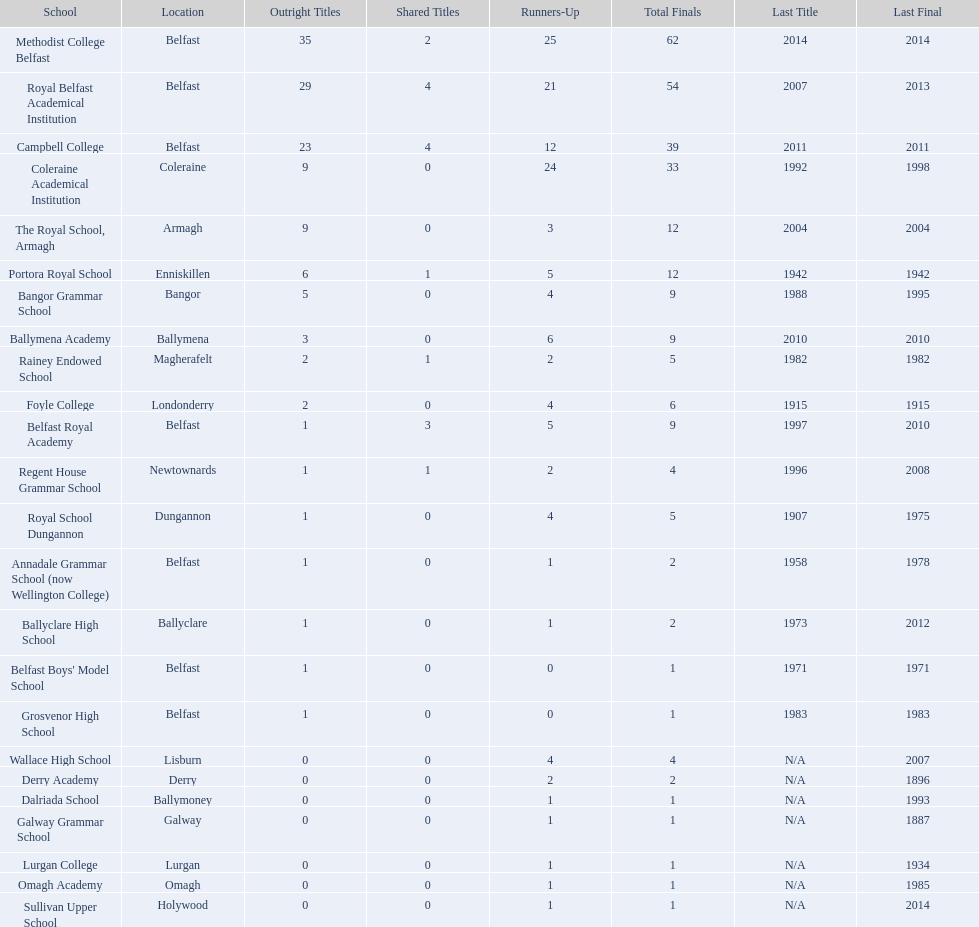How many educational institutions exist? Methodist College Belfast, Royal Belfast Academical Institution, Campbell College, Coleraine Academical Institution, The Royal School, Armagh, Portora Royal School, Bangor Grammar School, Ballymena Academy, Rainey Endowed School, Foyle College, Belfast Royal Academy, Regent House Grammar School, Royal School Dungannon, Annadale Grammar School (now Wellington College), Ballyclare High School, Belfast Boys' Model School, Grosvenor High School, Wallace High School, Derry Academy, Dalriada School, Galway Grammar School, Lurgan College, Omagh Academy, Sullivan Upper School. Can you give me this table as a dict? {'header': ['School', 'Location', 'Outright Titles', 'Shared Titles', 'Runners-Up', 'Total Finals', 'Last Title', 'Last Final'], 'rows': [['Methodist College Belfast', 'Belfast', '35', '2', '25', '62', '2014', '2014'], ['Royal Belfast Academical Institution', 'Belfast', '29', '4', '21', '54', '2007', '2013'], ['Campbell College', 'Belfast', '23', '4', '12', '39', '2011', '2011'], ['Coleraine Academical Institution', 'Coleraine', '9', '0', '24', '33', '1992', '1998'], ['The Royal School, Armagh', 'Armagh', '9', '0', '3', '12', '2004', '2004'], ['Portora Royal School', 'Enniskillen', '6', '1', '5', '12', '1942', '1942'], ['Bangor Grammar School', 'Bangor', '5', '0', '4', '9', '1988', '1995'], ['Ballymena Academy', 'Ballymena', '3', '0', '6', '9', '2010', '2010'], ['Rainey Endowed School', 'Magherafelt', '2', '1', '2', '5', '1982', '1982'], ['Foyle College', 'Londonderry', '2', '0', '4', '6', '1915', '1915'], ['Belfast Royal Academy', 'Belfast', '1', '3', '5', '9', '1997', '2010'], ['Regent House Grammar School', 'Newtownards', '1', '1', '2', '4', '1996', '2008'], ['Royal School Dungannon', 'Dungannon', '1', '0', '4', '5', '1907', '1975'], ['Annadale Grammar School (now Wellington College)', 'Belfast', '1', '0', '1', '2', '1958', '1978'], ['Ballyclare High School', 'Ballyclare', '1', '0', '1', '2', '1973', '2012'], ["Belfast Boys' Model School", 'Belfast', '1', '0', '0', '1', '1971', '1971'], ['Grosvenor High School', 'Belfast', '1', '0', '0', '1', '1983', '1983'], ['Wallace High School', 'Lisburn', '0', '0', '4', '4', 'N/A', '2007'], ['Derry Academy', 'Derry', '0', '0', '2', '2', 'N/A', '1896'], ['Dalriada School', 'Ballymoney', '0', '0', '1', '1', 'N/A', '1993'], ['Galway Grammar School', 'Galway', '0', '0', '1', '1', 'N/A', '1887'], ['Lurgan College', 'Lurgan', '0', '0', '1', '1', 'N/A', '1934'], ['Omagh Academy', 'Omagh', '0', '0', '1', '1', 'N/A', '1985'], ['Sullivan Upper School', 'Holywood', '0', '0', '1', '1', 'N/A', '2014']]} What is the number of undisputed titles held by the coleraine academical institution? 9. Is there another school with the same quantity of undisputed titles? The Royal School, Armagh. 